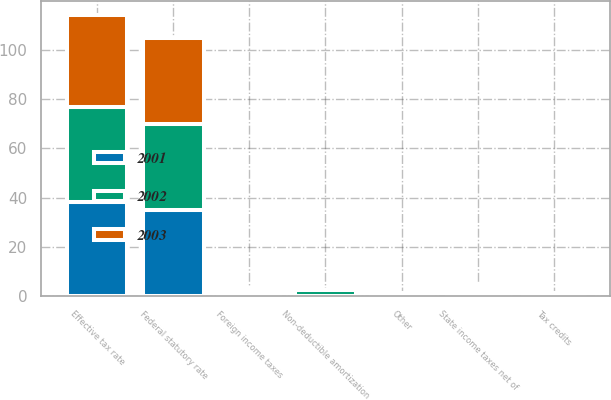Convert chart to OTSL. <chart><loc_0><loc_0><loc_500><loc_500><stacked_bar_chart><ecel><fcel>Federal statutory rate<fcel>State income taxes net of<fcel>Foreign income taxes<fcel>Non-deductible amortization<fcel>Tax credits<fcel>Other<fcel>Effective tax rate<nl><fcel>2003<fcel>35<fcel>1.6<fcel>0.9<fcel>0.1<fcel>0.2<fcel>0<fcel>37.4<nl><fcel>2001<fcel>35<fcel>1.7<fcel>1.3<fcel>0.2<fcel>0.4<fcel>0.4<fcel>38.2<nl><fcel>2002<fcel>35<fcel>1.7<fcel>1<fcel>2.3<fcel>0.8<fcel>0.7<fcel>38.5<nl></chart> 